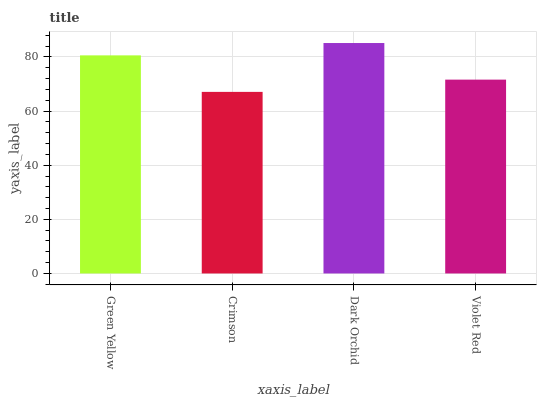Is Crimson the minimum?
Answer yes or no. Yes. Is Dark Orchid the maximum?
Answer yes or no. Yes. Is Dark Orchid the minimum?
Answer yes or no. No. Is Crimson the maximum?
Answer yes or no. No. Is Dark Orchid greater than Crimson?
Answer yes or no. Yes. Is Crimson less than Dark Orchid?
Answer yes or no. Yes. Is Crimson greater than Dark Orchid?
Answer yes or no. No. Is Dark Orchid less than Crimson?
Answer yes or no. No. Is Green Yellow the high median?
Answer yes or no. Yes. Is Violet Red the low median?
Answer yes or no. Yes. Is Crimson the high median?
Answer yes or no. No. Is Dark Orchid the low median?
Answer yes or no. No. 